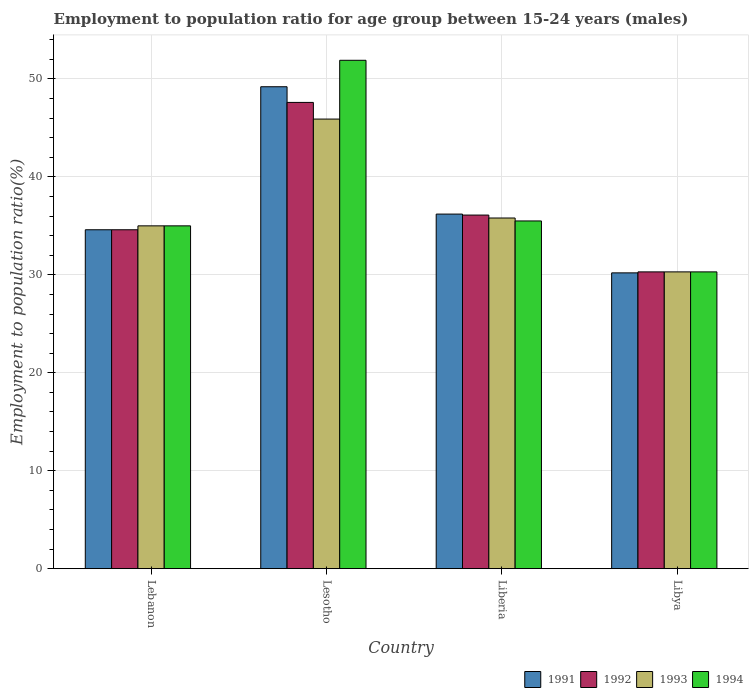Are the number of bars per tick equal to the number of legend labels?
Ensure brevity in your answer.  Yes. How many bars are there on the 2nd tick from the left?
Offer a very short reply. 4. How many bars are there on the 3rd tick from the right?
Provide a short and direct response. 4. What is the label of the 3rd group of bars from the left?
Your response must be concise. Liberia. What is the employment to population ratio in 1992 in Lesotho?
Provide a short and direct response. 47.6. Across all countries, what is the maximum employment to population ratio in 1994?
Provide a succinct answer. 51.9. Across all countries, what is the minimum employment to population ratio in 1992?
Make the answer very short. 30.3. In which country was the employment to population ratio in 1994 maximum?
Your answer should be compact. Lesotho. In which country was the employment to population ratio in 1994 minimum?
Give a very brief answer. Libya. What is the total employment to population ratio in 1991 in the graph?
Ensure brevity in your answer.  150.2. What is the difference between the employment to population ratio in 1991 in Lesotho and that in Liberia?
Provide a short and direct response. 13. What is the difference between the employment to population ratio in 1994 in Libya and the employment to population ratio in 1991 in Liberia?
Your response must be concise. -5.9. What is the average employment to population ratio in 1991 per country?
Provide a short and direct response. 37.55. What is the ratio of the employment to population ratio in 1993 in Lebanon to that in Libya?
Make the answer very short. 1.16. Is the difference between the employment to population ratio in 1992 in Lesotho and Liberia greater than the difference between the employment to population ratio in 1994 in Lesotho and Liberia?
Give a very brief answer. No. What is the difference between the highest and the second highest employment to population ratio in 1992?
Keep it short and to the point. -1.5. What is the difference between the highest and the lowest employment to population ratio in 1993?
Give a very brief answer. 15.6. In how many countries, is the employment to population ratio in 1993 greater than the average employment to population ratio in 1993 taken over all countries?
Your response must be concise. 1. Is it the case that in every country, the sum of the employment to population ratio in 1991 and employment to population ratio in 1994 is greater than the sum of employment to population ratio in 1992 and employment to population ratio in 1993?
Keep it short and to the point. No. What does the 2nd bar from the left in Libya represents?
Offer a terse response. 1992. Is it the case that in every country, the sum of the employment to population ratio in 1994 and employment to population ratio in 1991 is greater than the employment to population ratio in 1993?
Ensure brevity in your answer.  Yes. How many countries are there in the graph?
Your answer should be compact. 4. What is the difference between two consecutive major ticks on the Y-axis?
Offer a very short reply. 10. Does the graph contain any zero values?
Your answer should be compact. No. Does the graph contain grids?
Offer a very short reply. Yes. Where does the legend appear in the graph?
Your answer should be very brief. Bottom right. How are the legend labels stacked?
Give a very brief answer. Horizontal. What is the title of the graph?
Offer a very short reply. Employment to population ratio for age group between 15-24 years (males). Does "1990" appear as one of the legend labels in the graph?
Keep it short and to the point. No. What is the Employment to population ratio(%) of 1991 in Lebanon?
Offer a terse response. 34.6. What is the Employment to population ratio(%) in 1992 in Lebanon?
Provide a short and direct response. 34.6. What is the Employment to population ratio(%) in 1993 in Lebanon?
Ensure brevity in your answer.  35. What is the Employment to population ratio(%) in 1994 in Lebanon?
Give a very brief answer. 35. What is the Employment to population ratio(%) of 1991 in Lesotho?
Make the answer very short. 49.2. What is the Employment to population ratio(%) of 1992 in Lesotho?
Make the answer very short. 47.6. What is the Employment to population ratio(%) in 1993 in Lesotho?
Your answer should be very brief. 45.9. What is the Employment to population ratio(%) in 1994 in Lesotho?
Your answer should be very brief. 51.9. What is the Employment to population ratio(%) of 1991 in Liberia?
Ensure brevity in your answer.  36.2. What is the Employment to population ratio(%) in 1992 in Liberia?
Give a very brief answer. 36.1. What is the Employment to population ratio(%) in 1993 in Liberia?
Provide a short and direct response. 35.8. What is the Employment to population ratio(%) of 1994 in Liberia?
Offer a terse response. 35.5. What is the Employment to population ratio(%) in 1991 in Libya?
Provide a short and direct response. 30.2. What is the Employment to population ratio(%) of 1992 in Libya?
Your answer should be very brief. 30.3. What is the Employment to population ratio(%) in 1993 in Libya?
Provide a succinct answer. 30.3. What is the Employment to population ratio(%) of 1994 in Libya?
Your answer should be very brief. 30.3. Across all countries, what is the maximum Employment to population ratio(%) of 1991?
Your response must be concise. 49.2. Across all countries, what is the maximum Employment to population ratio(%) in 1992?
Ensure brevity in your answer.  47.6. Across all countries, what is the maximum Employment to population ratio(%) in 1993?
Offer a very short reply. 45.9. Across all countries, what is the maximum Employment to population ratio(%) in 1994?
Your answer should be compact. 51.9. Across all countries, what is the minimum Employment to population ratio(%) in 1991?
Give a very brief answer. 30.2. Across all countries, what is the minimum Employment to population ratio(%) in 1992?
Provide a succinct answer. 30.3. Across all countries, what is the minimum Employment to population ratio(%) in 1993?
Provide a short and direct response. 30.3. Across all countries, what is the minimum Employment to population ratio(%) of 1994?
Your response must be concise. 30.3. What is the total Employment to population ratio(%) of 1991 in the graph?
Give a very brief answer. 150.2. What is the total Employment to population ratio(%) in 1992 in the graph?
Your response must be concise. 148.6. What is the total Employment to population ratio(%) in 1993 in the graph?
Offer a very short reply. 147. What is the total Employment to population ratio(%) of 1994 in the graph?
Make the answer very short. 152.7. What is the difference between the Employment to population ratio(%) of 1991 in Lebanon and that in Lesotho?
Your response must be concise. -14.6. What is the difference between the Employment to population ratio(%) of 1992 in Lebanon and that in Lesotho?
Ensure brevity in your answer.  -13. What is the difference between the Employment to population ratio(%) in 1994 in Lebanon and that in Lesotho?
Provide a short and direct response. -16.9. What is the difference between the Employment to population ratio(%) in 1992 in Lebanon and that in Liberia?
Make the answer very short. -1.5. What is the difference between the Employment to population ratio(%) in 1993 in Lebanon and that in Liberia?
Provide a short and direct response. -0.8. What is the difference between the Employment to population ratio(%) of 1991 in Lebanon and that in Libya?
Offer a very short reply. 4.4. What is the difference between the Employment to population ratio(%) of 1992 in Lebanon and that in Libya?
Your answer should be compact. 4.3. What is the difference between the Employment to population ratio(%) in 1994 in Lesotho and that in Liberia?
Keep it short and to the point. 16.4. What is the difference between the Employment to population ratio(%) in 1991 in Lesotho and that in Libya?
Offer a terse response. 19. What is the difference between the Employment to population ratio(%) in 1992 in Lesotho and that in Libya?
Your response must be concise. 17.3. What is the difference between the Employment to population ratio(%) in 1993 in Lesotho and that in Libya?
Your answer should be very brief. 15.6. What is the difference between the Employment to population ratio(%) in 1994 in Lesotho and that in Libya?
Offer a very short reply. 21.6. What is the difference between the Employment to population ratio(%) in 1991 in Liberia and that in Libya?
Your answer should be very brief. 6. What is the difference between the Employment to population ratio(%) in 1994 in Liberia and that in Libya?
Make the answer very short. 5.2. What is the difference between the Employment to population ratio(%) in 1991 in Lebanon and the Employment to population ratio(%) in 1993 in Lesotho?
Make the answer very short. -11.3. What is the difference between the Employment to population ratio(%) of 1991 in Lebanon and the Employment to population ratio(%) of 1994 in Lesotho?
Ensure brevity in your answer.  -17.3. What is the difference between the Employment to population ratio(%) in 1992 in Lebanon and the Employment to population ratio(%) in 1994 in Lesotho?
Give a very brief answer. -17.3. What is the difference between the Employment to population ratio(%) in 1993 in Lebanon and the Employment to population ratio(%) in 1994 in Lesotho?
Make the answer very short. -16.9. What is the difference between the Employment to population ratio(%) in 1992 in Lebanon and the Employment to population ratio(%) in 1994 in Liberia?
Your answer should be very brief. -0.9. What is the difference between the Employment to population ratio(%) in 1991 in Lesotho and the Employment to population ratio(%) in 1993 in Liberia?
Provide a short and direct response. 13.4. What is the difference between the Employment to population ratio(%) of 1991 in Lesotho and the Employment to population ratio(%) of 1994 in Liberia?
Your answer should be very brief. 13.7. What is the difference between the Employment to population ratio(%) in 1992 in Lesotho and the Employment to population ratio(%) in 1993 in Liberia?
Keep it short and to the point. 11.8. What is the difference between the Employment to population ratio(%) in 1993 in Lesotho and the Employment to population ratio(%) in 1994 in Liberia?
Provide a short and direct response. 10.4. What is the difference between the Employment to population ratio(%) of 1992 in Lesotho and the Employment to population ratio(%) of 1993 in Libya?
Provide a short and direct response. 17.3. What is the difference between the Employment to population ratio(%) in 1991 in Liberia and the Employment to population ratio(%) in 1994 in Libya?
Provide a succinct answer. 5.9. What is the difference between the Employment to population ratio(%) in 1992 in Liberia and the Employment to population ratio(%) in 1993 in Libya?
Give a very brief answer. 5.8. What is the difference between the Employment to population ratio(%) of 1992 in Liberia and the Employment to population ratio(%) of 1994 in Libya?
Provide a short and direct response. 5.8. What is the difference between the Employment to population ratio(%) of 1993 in Liberia and the Employment to population ratio(%) of 1994 in Libya?
Offer a very short reply. 5.5. What is the average Employment to population ratio(%) in 1991 per country?
Offer a terse response. 37.55. What is the average Employment to population ratio(%) in 1992 per country?
Your answer should be compact. 37.15. What is the average Employment to population ratio(%) in 1993 per country?
Keep it short and to the point. 36.75. What is the average Employment to population ratio(%) in 1994 per country?
Ensure brevity in your answer.  38.17. What is the difference between the Employment to population ratio(%) in 1991 and Employment to population ratio(%) in 1993 in Lebanon?
Keep it short and to the point. -0.4. What is the difference between the Employment to population ratio(%) of 1991 and Employment to population ratio(%) of 1992 in Lesotho?
Give a very brief answer. 1.6. What is the difference between the Employment to population ratio(%) of 1991 and Employment to population ratio(%) of 1993 in Lesotho?
Your answer should be compact. 3.3. What is the difference between the Employment to population ratio(%) of 1992 and Employment to population ratio(%) of 1993 in Lesotho?
Offer a very short reply. 1.7. What is the difference between the Employment to population ratio(%) of 1992 and Employment to population ratio(%) of 1994 in Lesotho?
Ensure brevity in your answer.  -4.3. What is the difference between the Employment to population ratio(%) of 1993 and Employment to population ratio(%) of 1994 in Lesotho?
Provide a short and direct response. -6. What is the difference between the Employment to population ratio(%) of 1991 and Employment to population ratio(%) of 1994 in Libya?
Give a very brief answer. -0.1. What is the ratio of the Employment to population ratio(%) in 1991 in Lebanon to that in Lesotho?
Keep it short and to the point. 0.7. What is the ratio of the Employment to population ratio(%) in 1992 in Lebanon to that in Lesotho?
Your response must be concise. 0.73. What is the ratio of the Employment to population ratio(%) in 1993 in Lebanon to that in Lesotho?
Keep it short and to the point. 0.76. What is the ratio of the Employment to population ratio(%) of 1994 in Lebanon to that in Lesotho?
Provide a succinct answer. 0.67. What is the ratio of the Employment to population ratio(%) of 1991 in Lebanon to that in Liberia?
Make the answer very short. 0.96. What is the ratio of the Employment to population ratio(%) of 1992 in Lebanon to that in Liberia?
Offer a terse response. 0.96. What is the ratio of the Employment to population ratio(%) in 1993 in Lebanon to that in Liberia?
Ensure brevity in your answer.  0.98. What is the ratio of the Employment to population ratio(%) in 1994 in Lebanon to that in Liberia?
Give a very brief answer. 0.99. What is the ratio of the Employment to population ratio(%) of 1991 in Lebanon to that in Libya?
Your response must be concise. 1.15. What is the ratio of the Employment to population ratio(%) in 1992 in Lebanon to that in Libya?
Make the answer very short. 1.14. What is the ratio of the Employment to population ratio(%) in 1993 in Lebanon to that in Libya?
Your answer should be compact. 1.16. What is the ratio of the Employment to population ratio(%) in 1994 in Lebanon to that in Libya?
Your response must be concise. 1.16. What is the ratio of the Employment to population ratio(%) of 1991 in Lesotho to that in Liberia?
Make the answer very short. 1.36. What is the ratio of the Employment to population ratio(%) of 1992 in Lesotho to that in Liberia?
Make the answer very short. 1.32. What is the ratio of the Employment to population ratio(%) of 1993 in Lesotho to that in Liberia?
Offer a terse response. 1.28. What is the ratio of the Employment to population ratio(%) in 1994 in Lesotho to that in Liberia?
Provide a succinct answer. 1.46. What is the ratio of the Employment to population ratio(%) of 1991 in Lesotho to that in Libya?
Ensure brevity in your answer.  1.63. What is the ratio of the Employment to population ratio(%) of 1992 in Lesotho to that in Libya?
Offer a terse response. 1.57. What is the ratio of the Employment to population ratio(%) of 1993 in Lesotho to that in Libya?
Offer a very short reply. 1.51. What is the ratio of the Employment to population ratio(%) in 1994 in Lesotho to that in Libya?
Your answer should be compact. 1.71. What is the ratio of the Employment to population ratio(%) of 1991 in Liberia to that in Libya?
Provide a succinct answer. 1.2. What is the ratio of the Employment to population ratio(%) of 1992 in Liberia to that in Libya?
Your response must be concise. 1.19. What is the ratio of the Employment to population ratio(%) in 1993 in Liberia to that in Libya?
Your response must be concise. 1.18. What is the ratio of the Employment to population ratio(%) of 1994 in Liberia to that in Libya?
Your answer should be compact. 1.17. What is the difference between the highest and the second highest Employment to population ratio(%) of 1991?
Make the answer very short. 13. What is the difference between the highest and the second highest Employment to population ratio(%) of 1992?
Make the answer very short. 11.5. What is the difference between the highest and the second highest Employment to population ratio(%) in 1993?
Your answer should be compact. 10.1. What is the difference between the highest and the lowest Employment to population ratio(%) in 1991?
Your response must be concise. 19. What is the difference between the highest and the lowest Employment to population ratio(%) in 1993?
Your answer should be compact. 15.6. What is the difference between the highest and the lowest Employment to population ratio(%) in 1994?
Provide a short and direct response. 21.6. 